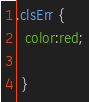Convert code to text. <code><loc_0><loc_0><loc_500><loc_500><_CSS_>.clsErr {
  color:red;
  
 }
</code> 